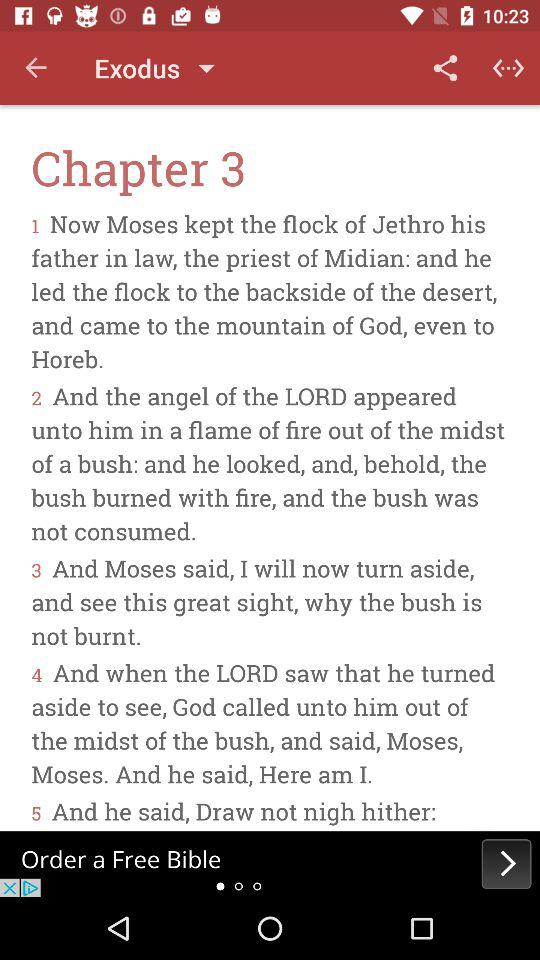How many pages are in the chapter?
When the provided information is insufficient, respond with <no answer>. <no answer> 